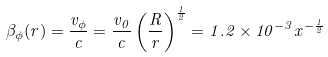<formula> <loc_0><loc_0><loc_500><loc_500>\beta _ { \phi } ( r ) = \frac { v _ { \phi } } { c } = \frac { v _ { 0 } } { c } \left ( \frac { R } { r } \right ) ^ { \frac { 1 } { 2 } } = 1 . 2 \times 1 0 ^ { - 3 } x ^ { - \frac { 1 } { 2 } }</formula> 